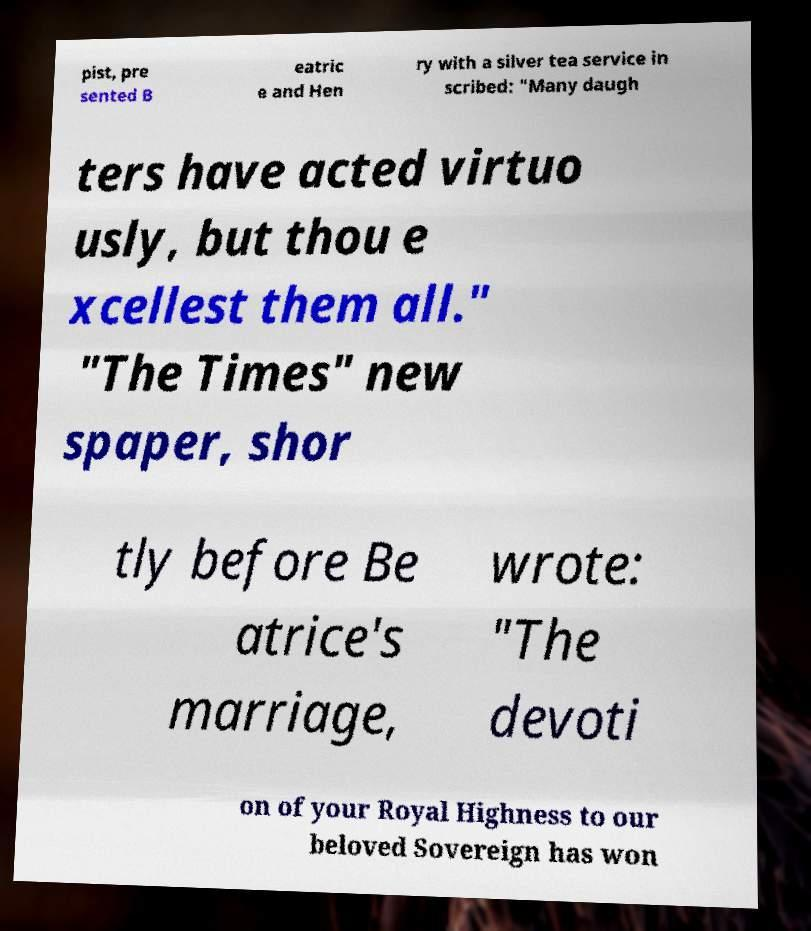Could you assist in decoding the text presented in this image and type it out clearly? pist, pre sented B eatric e and Hen ry with a silver tea service in scribed: "Many daugh ters have acted virtuo usly, but thou e xcellest them all." "The Times" new spaper, shor tly before Be atrice's marriage, wrote: "The devoti on of your Royal Highness to our beloved Sovereign has won 